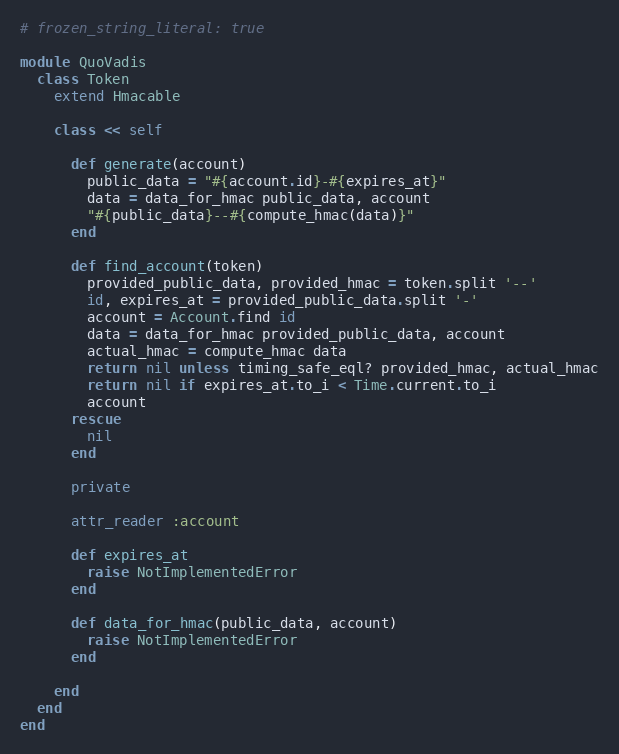<code> <loc_0><loc_0><loc_500><loc_500><_Ruby_># frozen_string_literal: true

module QuoVadis
  class Token
    extend Hmacable

    class << self

      def generate(account)
        public_data = "#{account.id}-#{expires_at}"
        data = data_for_hmac public_data, account
        "#{public_data}--#{compute_hmac(data)}"
      end

      def find_account(token)
        provided_public_data, provided_hmac = token.split '--'
        id, expires_at = provided_public_data.split '-'
        account = Account.find id
        data = data_for_hmac provided_public_data, account
        actual_hmac = compute_hmac data
        return nil unless timing_safe_eql? provided_hmac, actual_hmac
        return nil if expires_at.to_i < Time.current.to_i
        account
      rescue
        nil
      end

      private

      attr_reader :account

      def expires_at
        raise NotImplementedError
      end

      def data_for_hmac(public_data, account)
        raise NotImplementedError
      end

    end
  end
end
</code> 